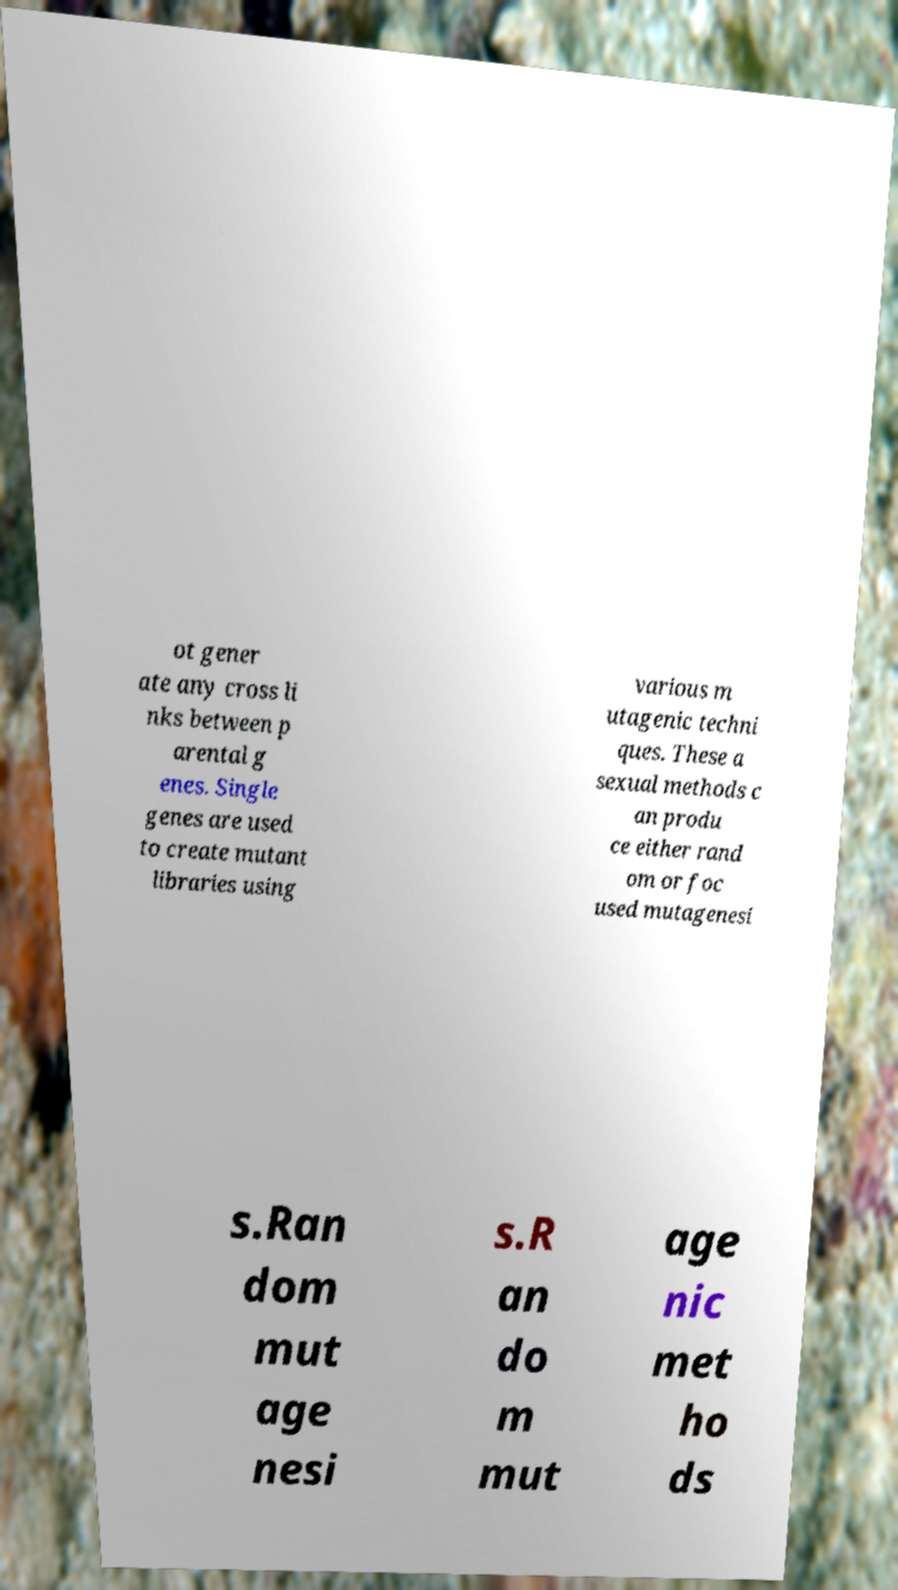I need the written content from this picture converted into text. Can you do that? ot gener ate any cross li nks between p arental g enes. Single genes are used to create mutant libraries using various m utagenic techni ques. These a sexual methods c an produ ce either rand om or foc used mutagenesi s.Ran dom mut age nesi s.R an do m mut age nic met ho ds 